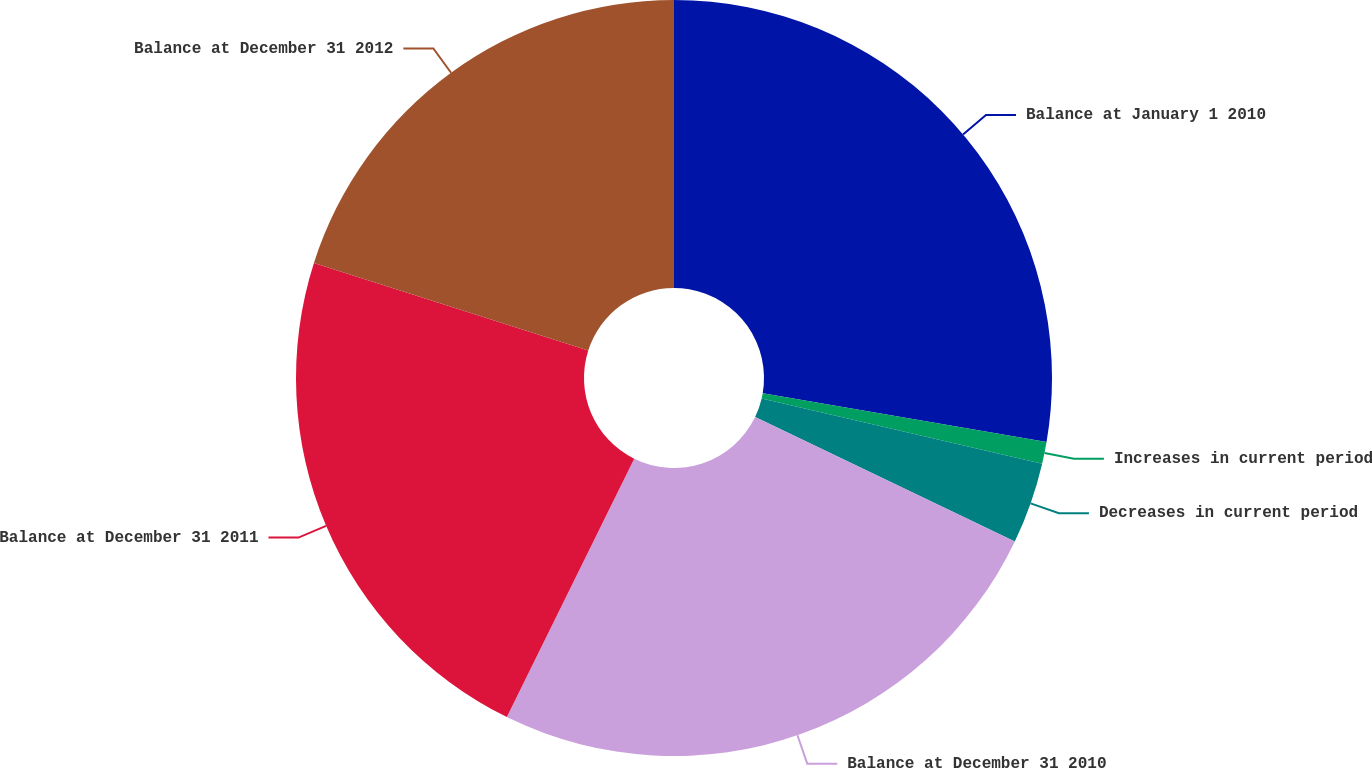Convert chart to OTSL. <chart><loc_0><loc_0><loc_500><loc_500><pie_chart><fcel>Balance at January 1 2010<fcel>Increases in current period<fcel>Decreases in current period<fcel>Balance at December 31 2010<fcel>Balance at December 31 2011<fcel>Balance at December 31 2012<nl><fcel>27.71%<fcel>0.93%<fcel>3.48%<fcel>25.17%<fcel>22.63%<fcel>20.08%<nl></chart> 